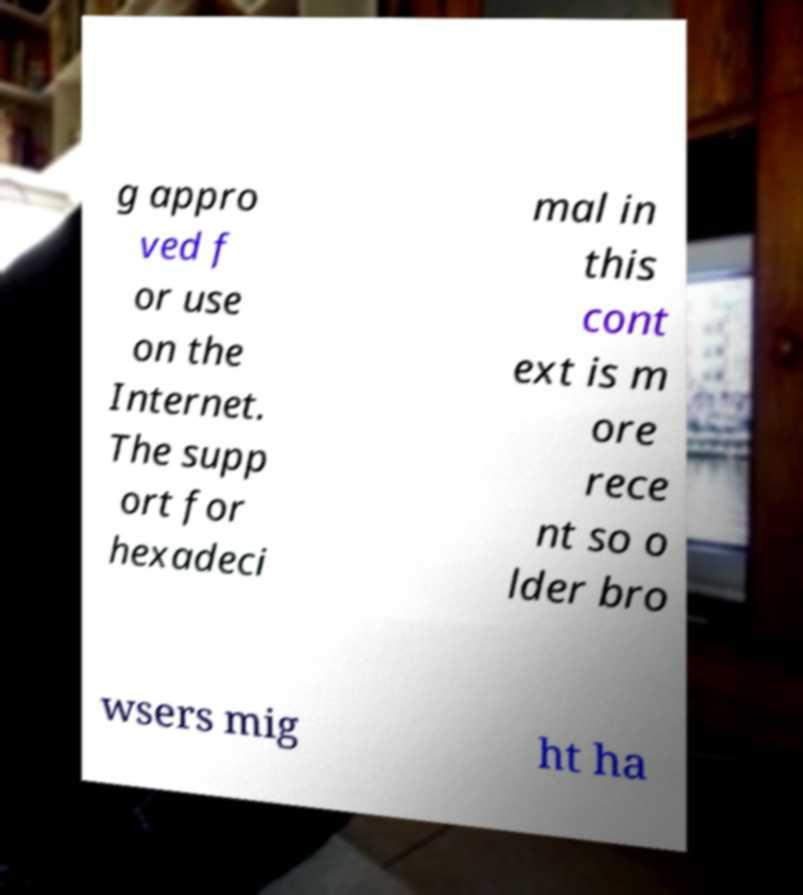There's text embedded in this image that I need extracted. Can you transcribe it verbatim? g appro ved f or use on the Internet. The supp ort for hexadeci mal in this cont ext is m ore rece nt so o lder bro wsers mig ht ha 